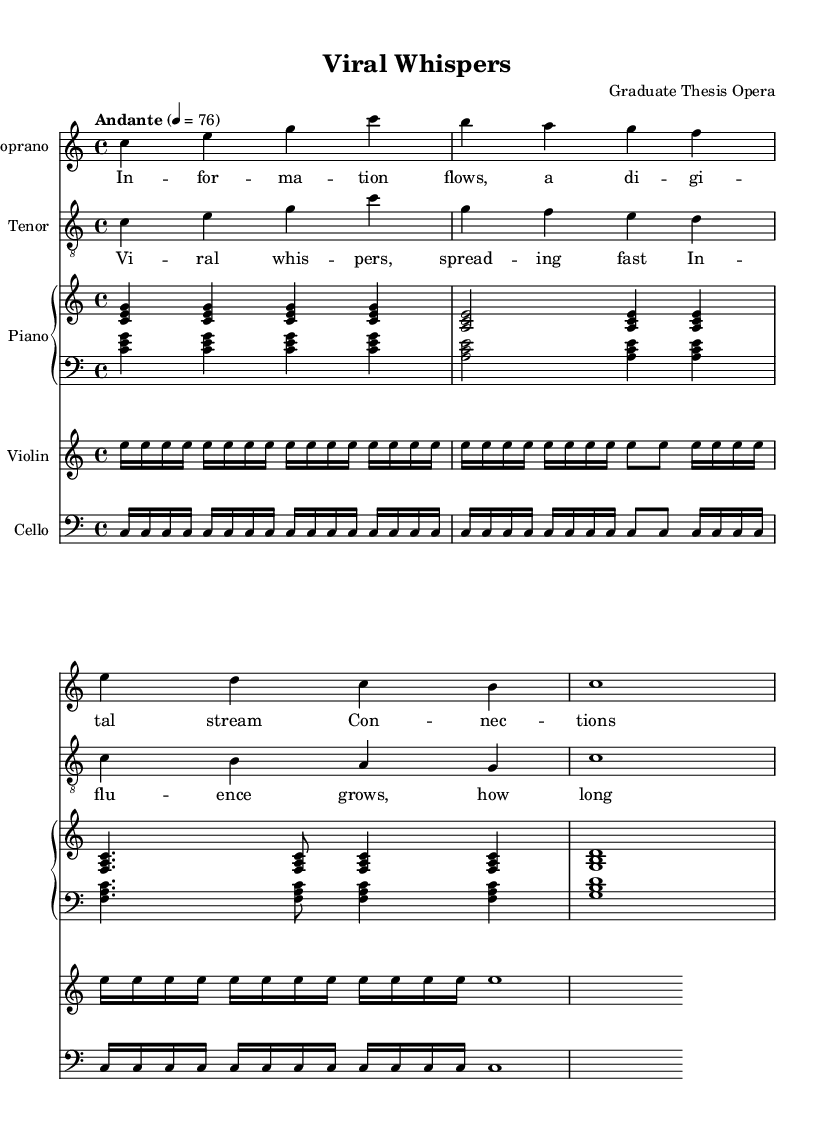What is the time signature of this music? The time signature can be found at the beginning of the score and is written as 4/4, which indicates that there are four beats in a measure and a quarter note gets one beat.
Answer: 4/4 What is the key signature of this music? The key signature appears at the start of the score, showing that there are no sharps or flats, indicating it is in C major.
Answer: C major What is the tempo marking of this piece? The tempo marking is found above the staff and states "Andante," which indicates a moderate walking pace, with a specific metronome mark of 76 beats per minute.
Answer: Andante How many measures are in the soprano part? Counting the measures in the soprano part, we can see there are four measures present in the provided section, which is verified by the bar lines.
Answer: 4 What type of ensemble is this piece written for? Analyzing the score, the parts indicate that it is for a vocal ensemble (soprano and tenor) accompanied by piano, violin, and cello, which constitutes an operatic style ensemble.
Answer: Vocal and instrumental What lyrical theme is presented in the verse? The verse lyrics describe the flow of information and social connections, highlighting the complexities behind digital communication, indicating a thematic exploration of information dynamics.
Answer: Information flow How does the chorus relate to the overall theme? The chorus reflects a sense of urgency and the impact of social influence; it discusses the rapid spread of ideas or "viral whispers," which parallels the social networks addressed in the opera's theme.
Answer: Viral whispers 